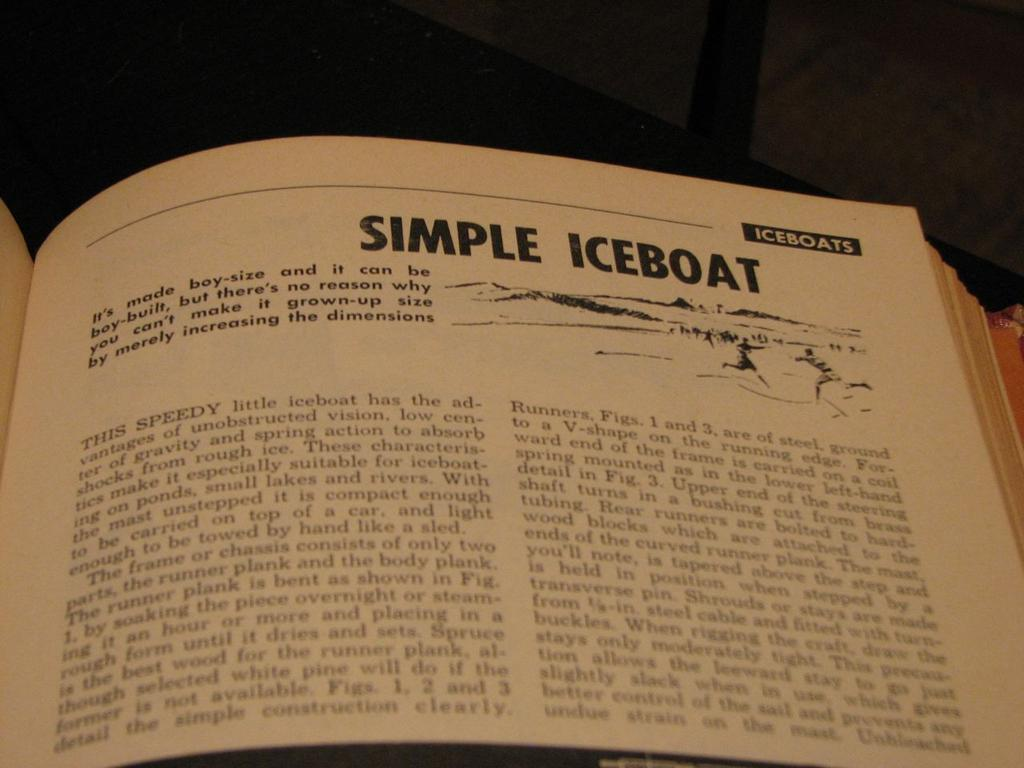Provide a one-sentence caption for the provided image. A book is opened to a page that reads Simple Iceboat. 